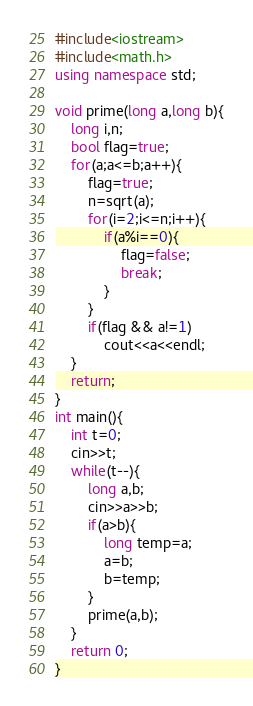Convert code to text. <code><loc_0><loc_0><loc_500><loc_500><_C++_>#include<iostream>
#include<math.h>
using namespace std;

void prime(long a,long b){
    long i,n;
    bool flag=true;
    for(a;a<=b;a++){
        flag=true;
        n=sqrt(a);
        for(i=2;i<=n;i++){
            if(a%i==0){
                flag=false;
                break;
            }
        }
        if(flag && a!=1)
            cout<<a<<endl;
    }
    return;
}
int main(){
    int t=0;
    cin>>t;
    while(t--){
        long a,b;
        cin>>a>>b;
        if(a>b){
            long temp=a;
            a=b;
            b=temp;
        }
        prime(a,b);
    }
    return 0;
}
</code> 